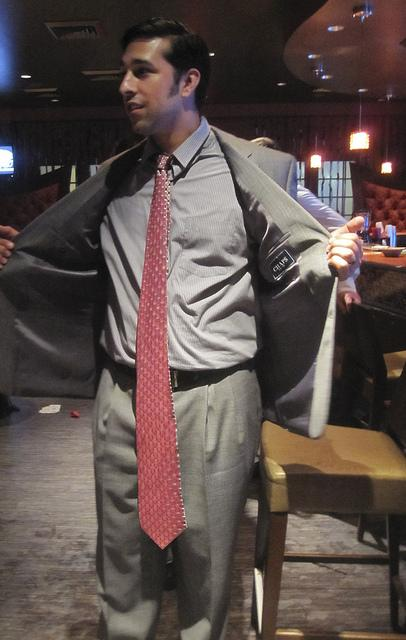What is the problem with this tie?

Choices:
A) too long
B) too feminine
C) too bright
D) too short too long 